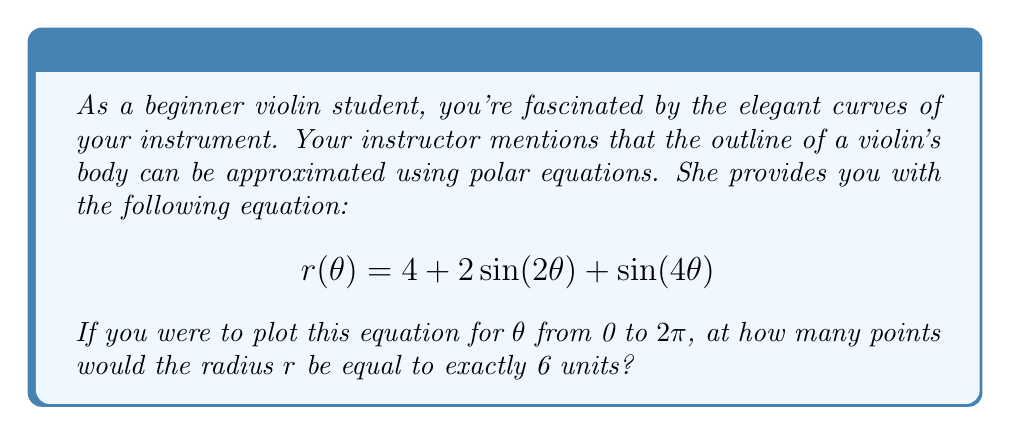What is the answer to this math problem? Let's approach this step-by-step:

1) The question is asking for the number of times $r(\theta) = 6$. So we need to solve the equation:

   $$6 = 4 + 2\sin(2\theta) + \sin(4\theta)$$

2) Rearranging the equation:

   $$2 = 2\sin(2\theta) + \sin(4\theta)$$

3) This is a complex trigonometric equation. To solve it, let's consider the maximum and minimum values of the right-hand side:

   - $\sin(2\theta)$ has a range of [-1, 1], so $2\sin(2\theta)$ has a range of [-2, 2]
   - $\sin(4\theta)$ has a range of [-1, 1]

4) The maximum value of the right-hand side occurs when both terms are at their maximum:

   $$2 + 1 = 3$$

   The minimum value occurs when both terms are at their minimum:

   $$-2 - 1 = -3$$

5) Since 2 falls within this range [-3, 3], there will be solutions to this equation.

6) Due to the periodic nature of sine functions, this equation will have multiple solutions within the range $[0, 2\pi]$.

7) Specifically, since we have $\sin(2\theta)$ and $\sin(4\theta)$, the equation will repeat four times within $[0, 2\pi]$.

8) Each repetition will yield two solutions (one where the function is increasing and one where it's decreasing).

9) Therefore, there will be $4 * 2 = 8$ solutions in total.
Answer: The radius $r$ will be equal to exactly 6 units at 8 points when $\theta$ varies from 0 to $2\pi$. 